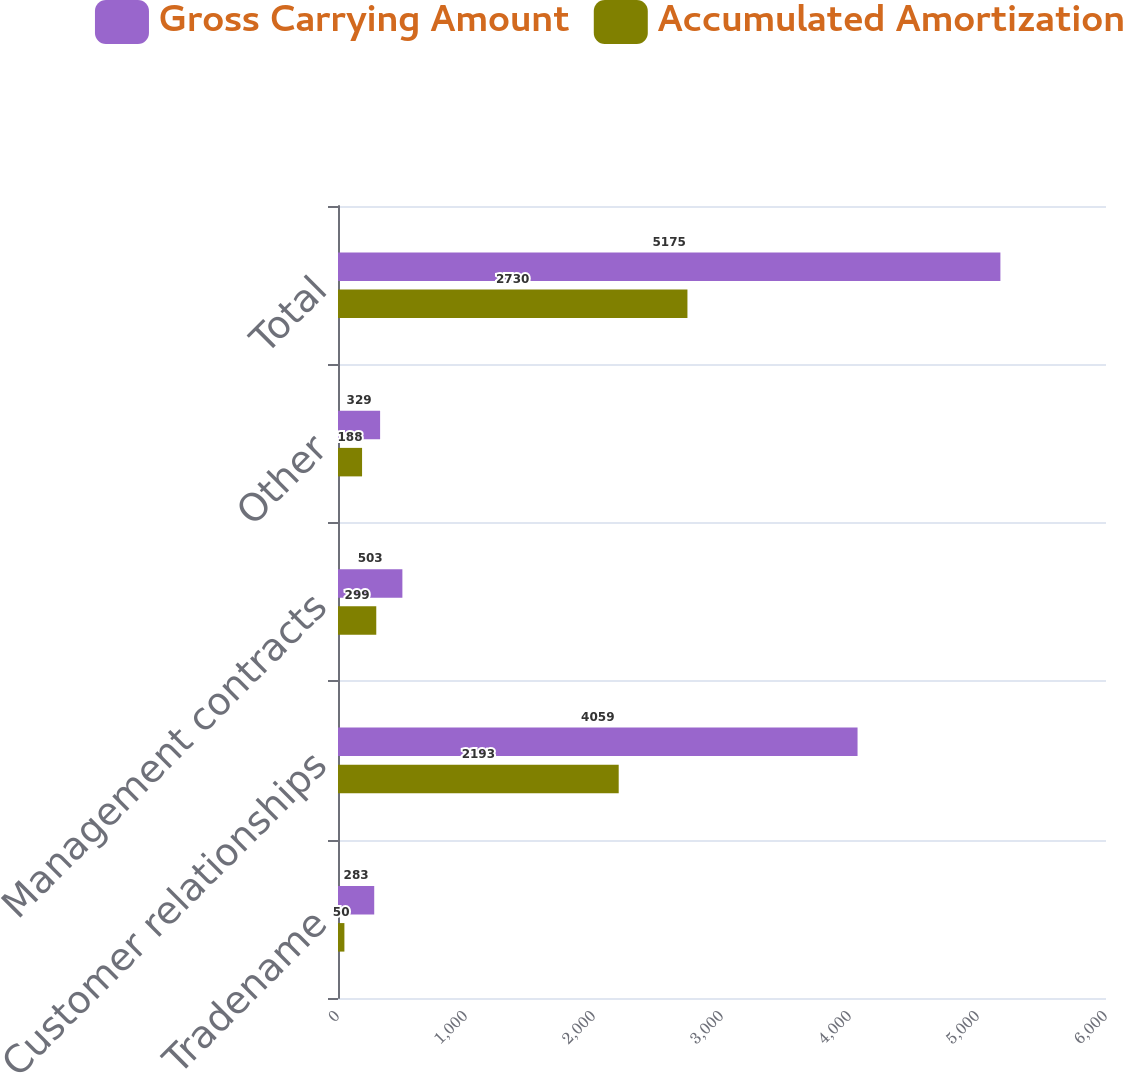<chart> <loc_0><loc_0><loc_500><loc_500><stacked_bar_chart><ecel><fcel>Tradename<fcel>Customer relationships<fcel>Management contracts<fcel>Other<fcel>Total<nl><fcel>Gross Carrying Amount<fcel>283<fcel>4059<fcel>503<fcel>329<fcel>5175<nl><fcel>Accumulated Amortization<fcel>50<fcel>2193<fcel>299<fcel>188<fcel>2730<nl></chart> 